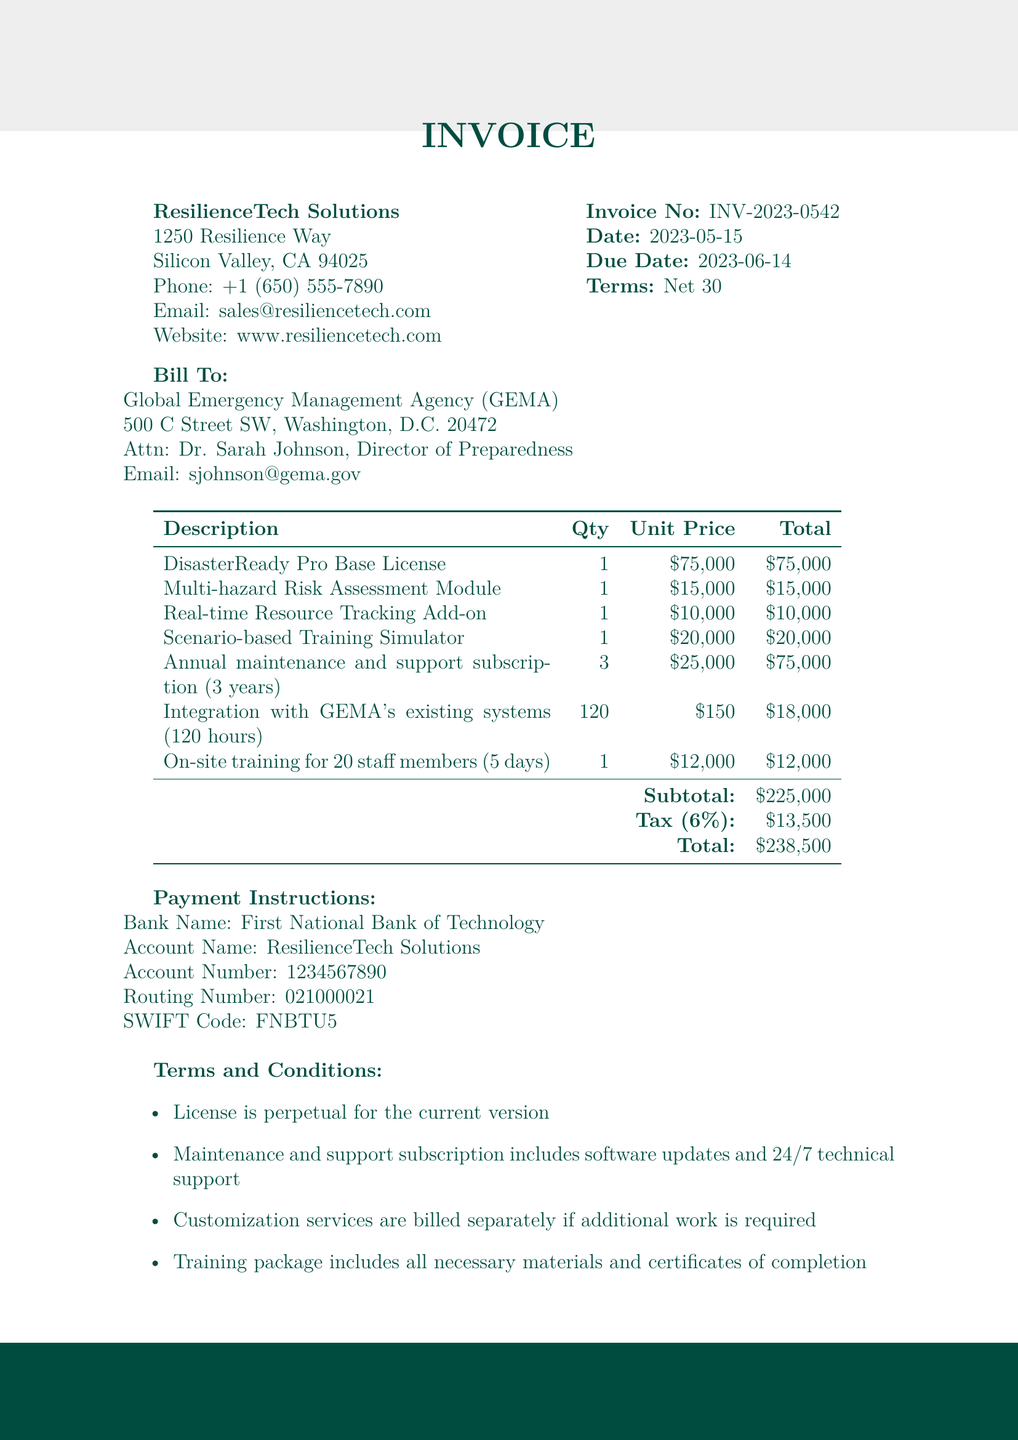What is the provider name? The provider name is listed under company_info in the document.
Answer: ResilienceTech Solutions What is the client name? The client name is found under the client_info section of the document.
Answer: Global Emergency Management Agency (GEMA) What is the total amount due? The total amount is the final figure calculated in the total_amount section of the document.
Answer: $238,500 What is the due date of the invoice? The due date is specified in the invoice_details section of the document.
Answer: 2023-06-14 How many hours are allocated for customization services? The hours allocated are mentioned in the customization_services section of the document.
Answer: 120 What is the annual maintenance fee? The annual maintenance fee is the price_per_year specified in the subscription_fees section of the document.
Answer: $25,000 What is the duration of the training package? The duration of the training package is detailed in the training_package section.
Answer: 5 days What is the total for the Scenario-based Training Simulator? The total for the Scenario-based Training Simulator can be found in the line_items section of the document.
Answer: $20,000 What types of support are included in the maintenance subscription? The support included is outlined in the terms_and_conditions section of the document.
Answer: Software updates and 24/7 technical support 